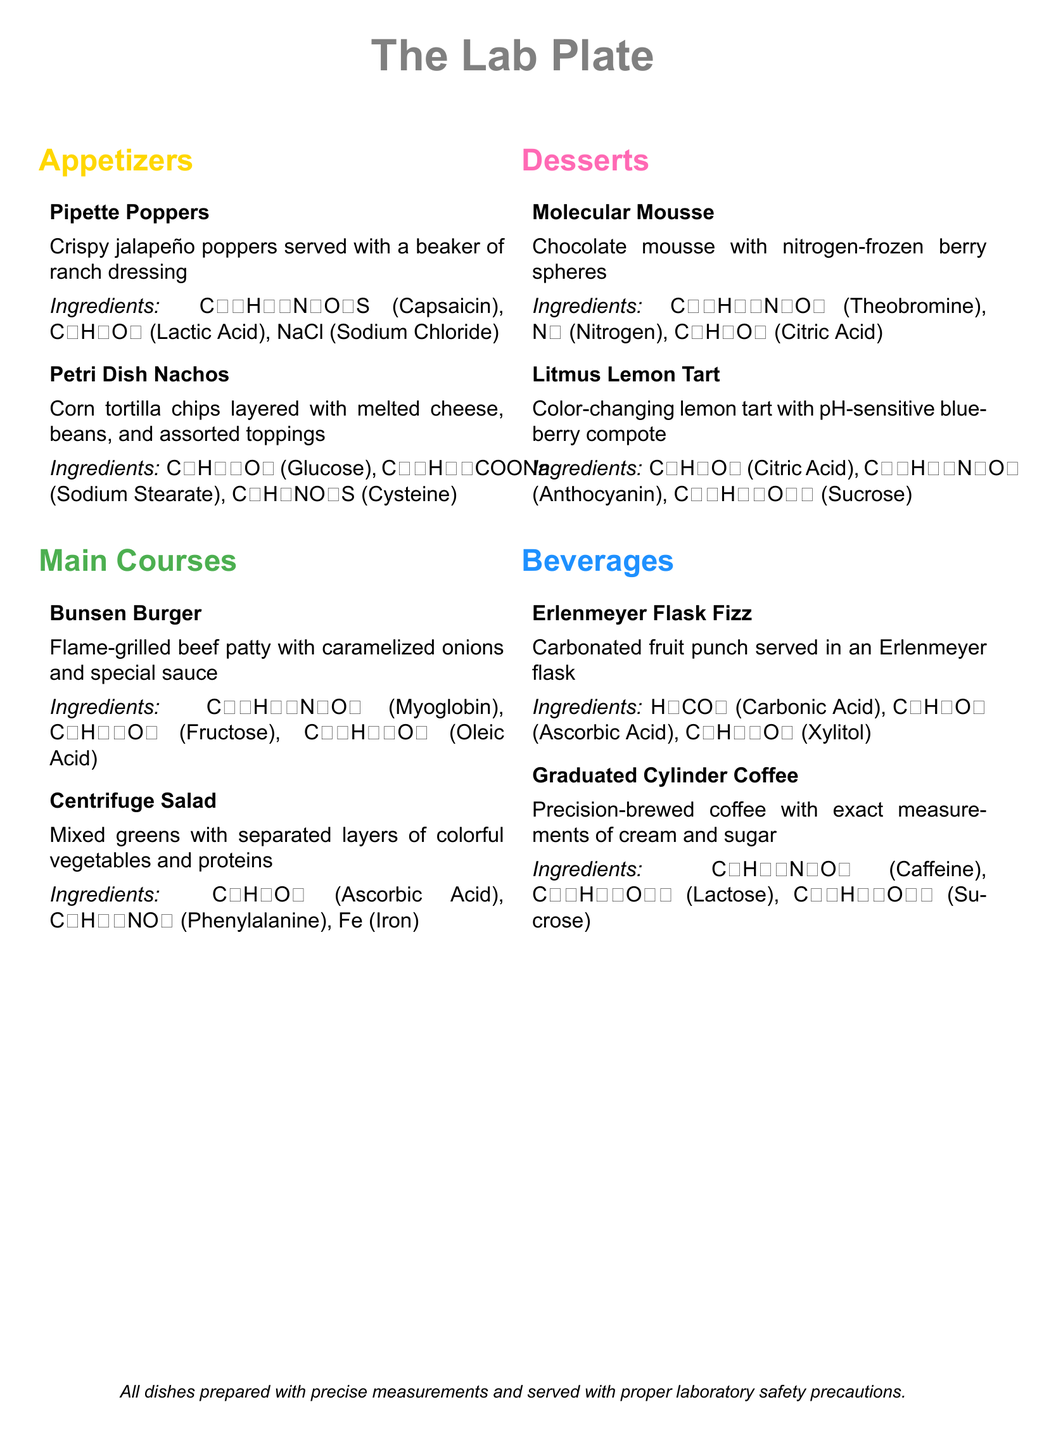what are the colors used for appetizers? The appetizers are labeled using the color yellow, as indicated by the hex code of the appetizer section.
Answer: yellow how many main courses are listed? The main courses section contains two items, indicating the total number of main courses on the menu.
Answer: two what is the first dessert offered? The first dessert listed in the document is a chocolate dessert with a specific preparation method.
Answer: Molecular Mousse which ingredient is common in both the Pipette Poppers and Petri Dish Nachos? Both dishes contain an ingredient that is commonly found in many foods and has a specific chemical formula.
Answer: Glucose what type of drink is served in an Erlenmeyer flask? The beverage that is served in this specific type of glassware is a type of fruit punch with carbonation.
Answer: Carbonated fruit punch what is the scientific name of the main ingredient in Bunsen Burger? The primary protein component in this dish has a specific molecular formula reflecting its biochemical structure.
Answer: Myoglobin which dessert undergoes a color change? A dessert described with a specific pH effect is mentioned as having a property that involves color change when reacting.
Answer: Litmus Lemon Tart what type of salad is offered as a main course? The main course option that features a layer of mixed greens and other ingredients is specifically named for a laboratory technique.
Answer: Centrifuge Salad how is the Graduated Cylinder Coffee prepared? The coffee is brewed using a method that ensures precise measurements of its additive components.
Answer: Precision-brewed 